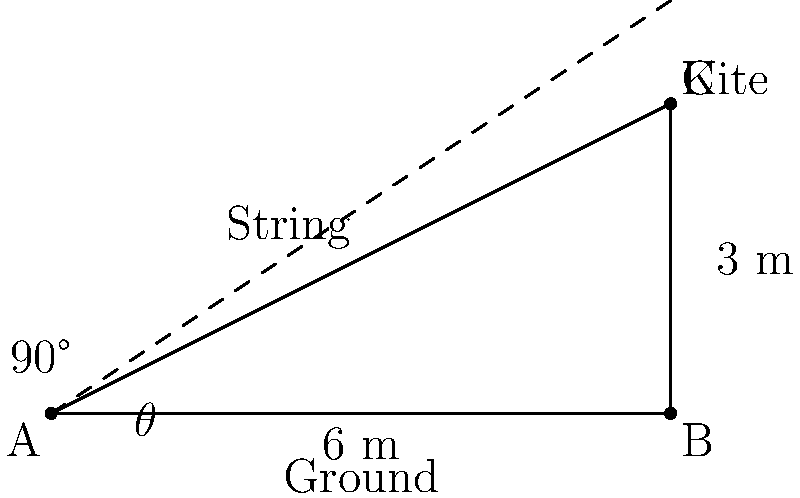During a family kite-flying outing, your child asks about the angle at which the kite string is elevated. The kite is flying directly above a point 6 meters away from where you're standing, and it's 3 meters high. What is the angle of elevation (θ) of the kite string? Let's approach this step-by-step:

1) The situation forms a right-angled triangle. We need to find the angle θ.

2) We know:
   - The adjacent side (ground distance) = 6 meters
   - The opposite side (height) = 3 meters

3) In a right-angled triangle, tan(θ) = opposite / adjacent

4) So, tan(θ) = 3 / 6 = 1 / 2

5) To find θ, we need to calculate the inverse tangent (arctan or tan^(-1)):

   θ = tan^(-1)(1/2)

6) Using a calculator or trigonometric tables:

   θ ≈ 26.57°

7) Rounding to the nearest whole degree:

   θ ≈ 27°

This problem provides an excellent opportunity to discuss real-world applications of trigonometry with your child while enjoying outdoor family time.
Answer: $27°$ 